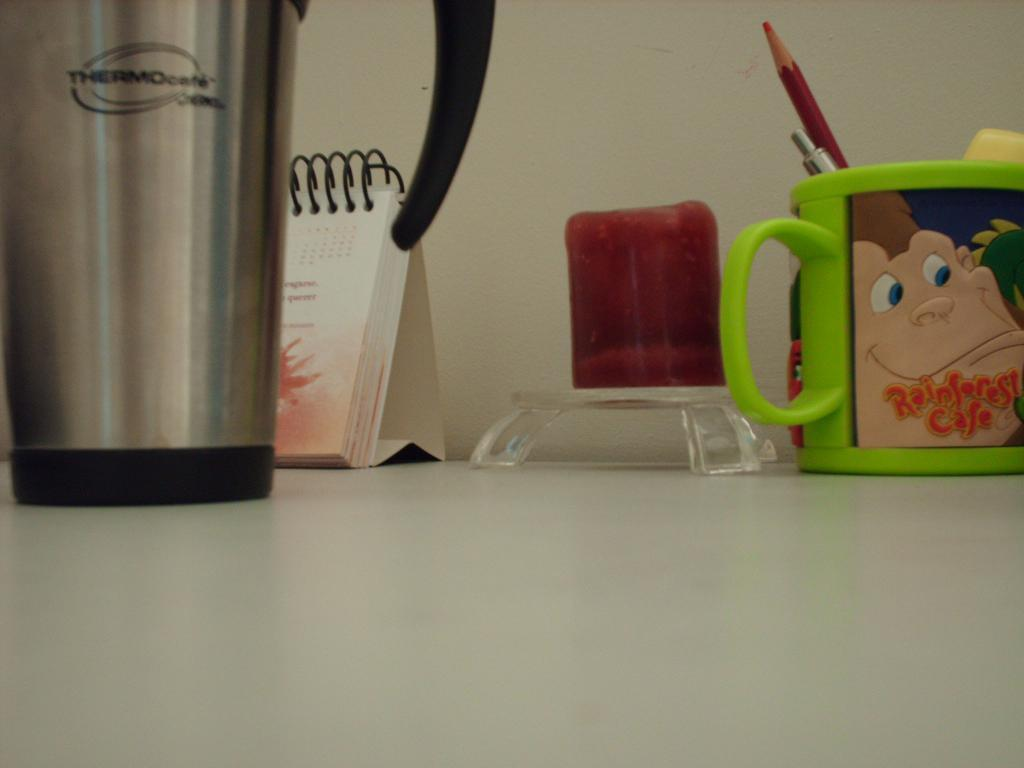What is the color of the wall in the image? The wall in the image is white. What can be seen on the wall in the image? There is a flask in the image. What else is present in the image besides the wall and flask? There is a book and a cup on a table in the image. Is there any snow visible in the image? No, there is no snow present in the image. What type of drink is being served in the cup in the image? The image does not specify the contents of the cup, so it cannot be determined if it contains eggnog or any other drink. 